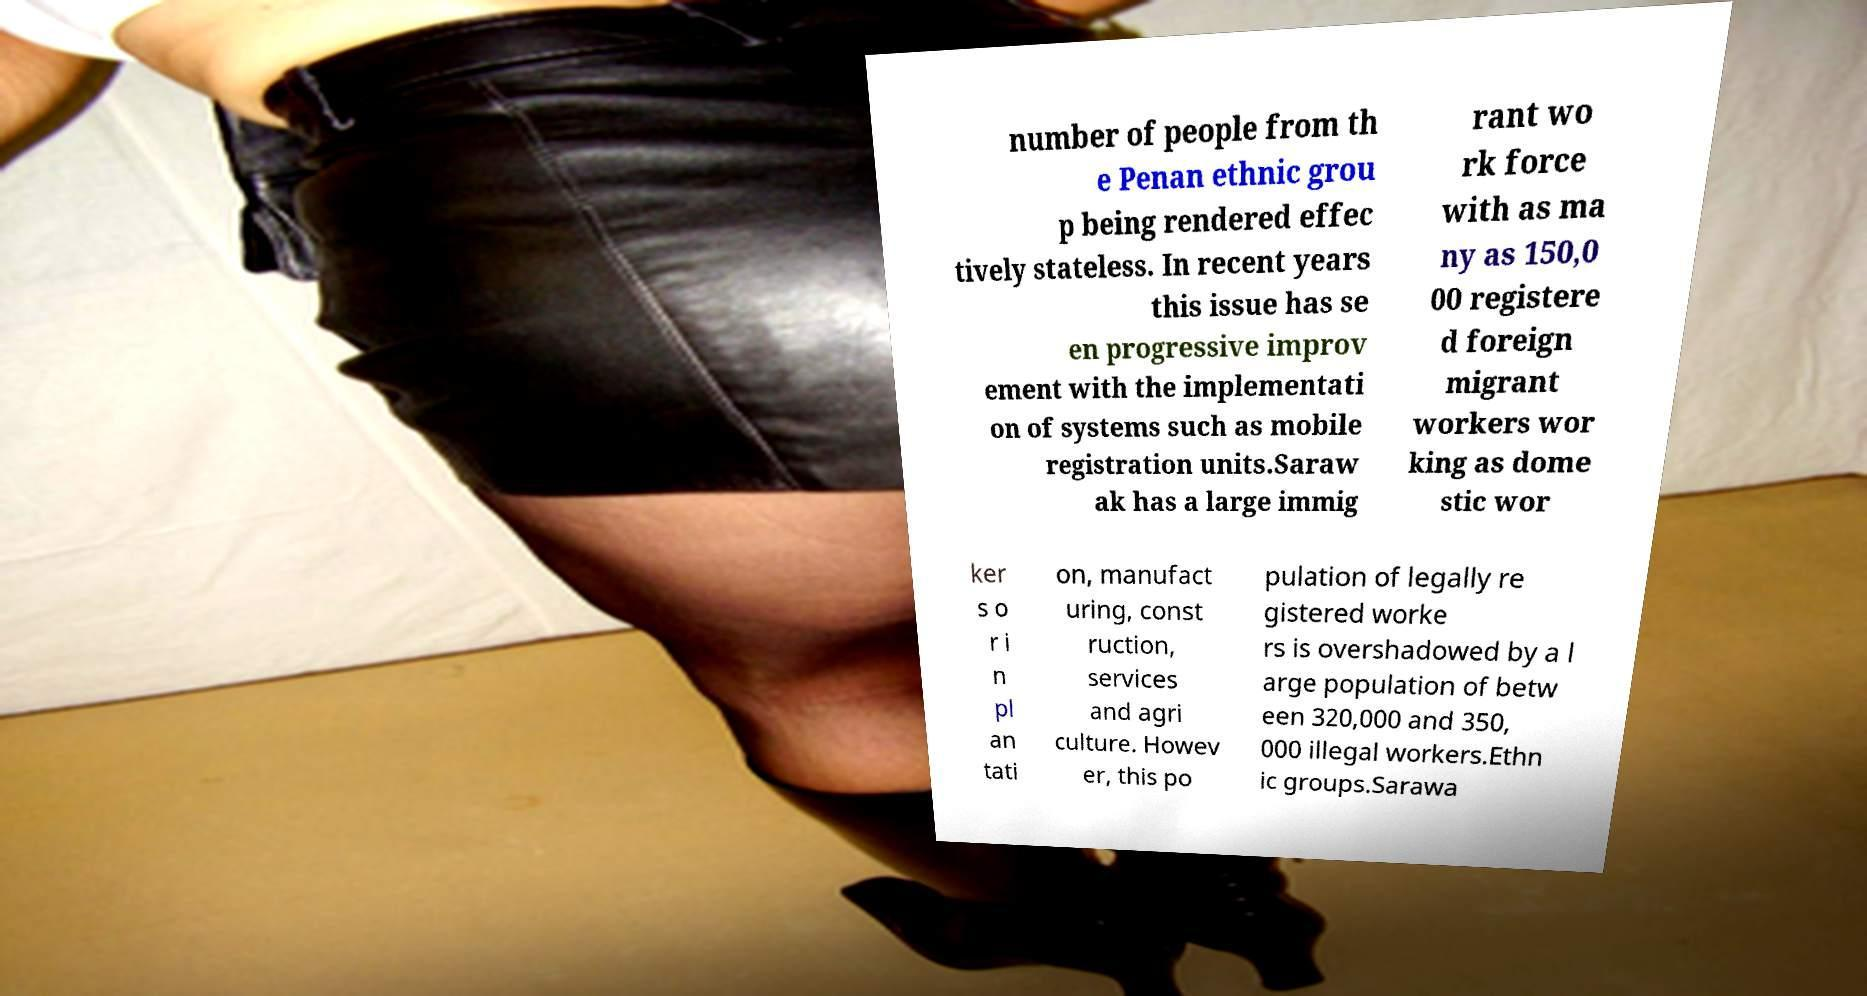What messages or text are displayed in this image? I need them in a readable, typed format. number of people from th e Penan ethnic grou p being rendered effec tively stateless. In recent years this issue has se en progressive improv ement with the implementati on of systems such as mobile registration units.Saraw ak has a large immig rant wo rk force with as ma ny as 150,0 00 registere d foreign migrant workers wor king as dome stic wor ker s o r i n pl an tati on, manufact uring, const ruction, services and agri culture. Howev er, this po pulation of legally re gistered worke rs is overshadowed by a l arge population of betw een 320,000 and 350, 000 illegal workers.Ethn ic groups.Sarawa 